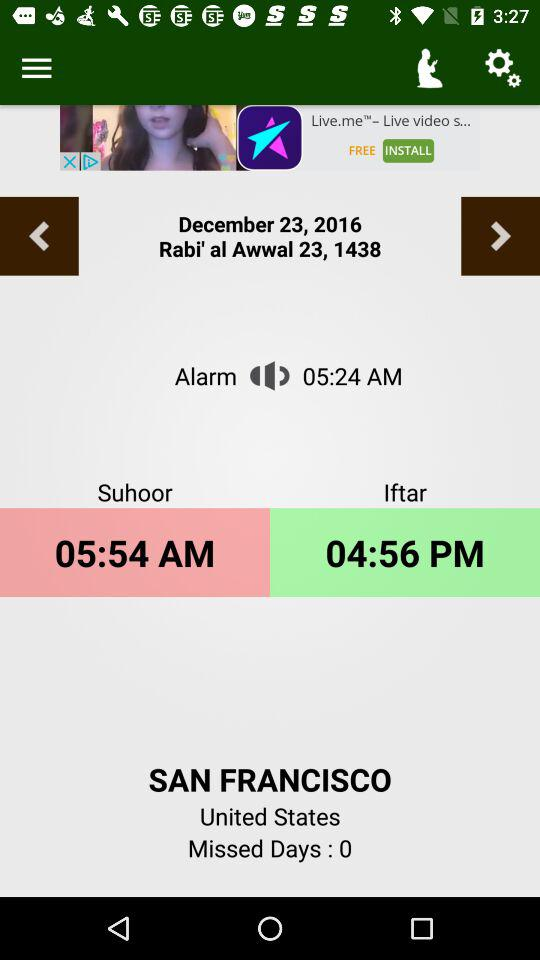How many missed days are there? There are 0 missed days. 